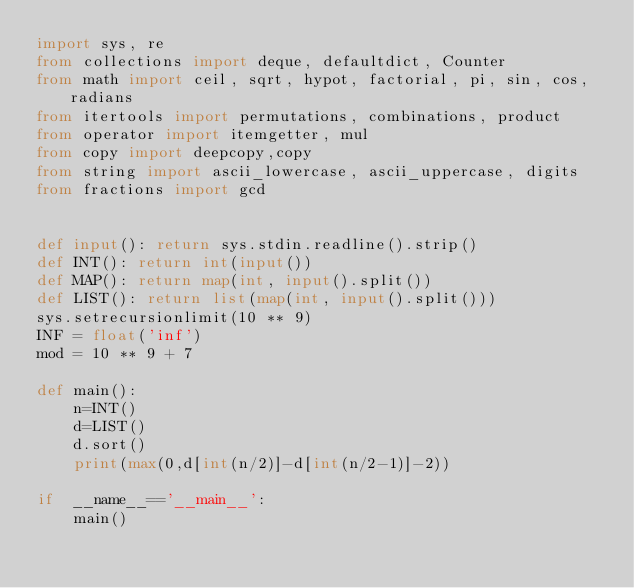<code> <loc_0><loc_0><loc_500><loc_500><_Python_>import sys, re
from collections import deque, defaultdict, Counter
from math import ceil, sqrt, hypot, factorial, pi, sin, cos, radians
from itertools import permutations, combinations, product
from operator import itemgetter, mul
from copy import deepcopy,copy
from string import ascii_lowercase, ascii_uppercase, digits
from fractions import gcd


def input(): return sys.stdin.readline().strip()
def INT(): return int(input())
def MAP(): return map(int, input().split())
def LIST(): return list(map(int, input().split()))
sys.setrecursionlimit(10 ** 9)
INF = float('inf')
mod = 10 ** 9 + 7

def main():
    n=INT()
    d=LIST()
    d.sort()
    print(max(0,d[int(n/2)]-d[int(n/2-1)]-2))

if  __name__=='__main__':
    main()
</code> 